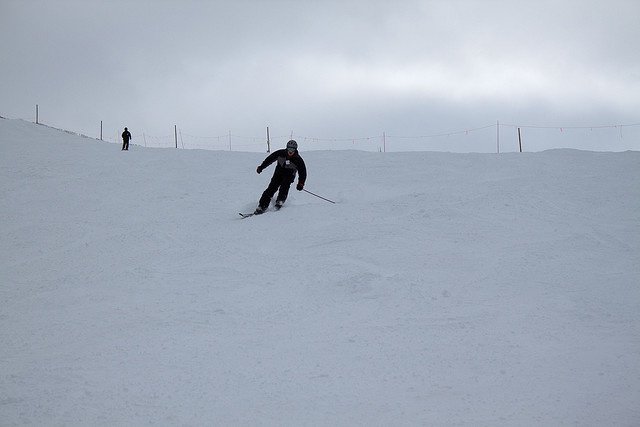Describe the objects in this image and their specific colors. I can see people in darkgray, black, and gray tones, people in darkgray, black, and lightgray tones, and skis in darkgray, gray, and black tones in this image. 